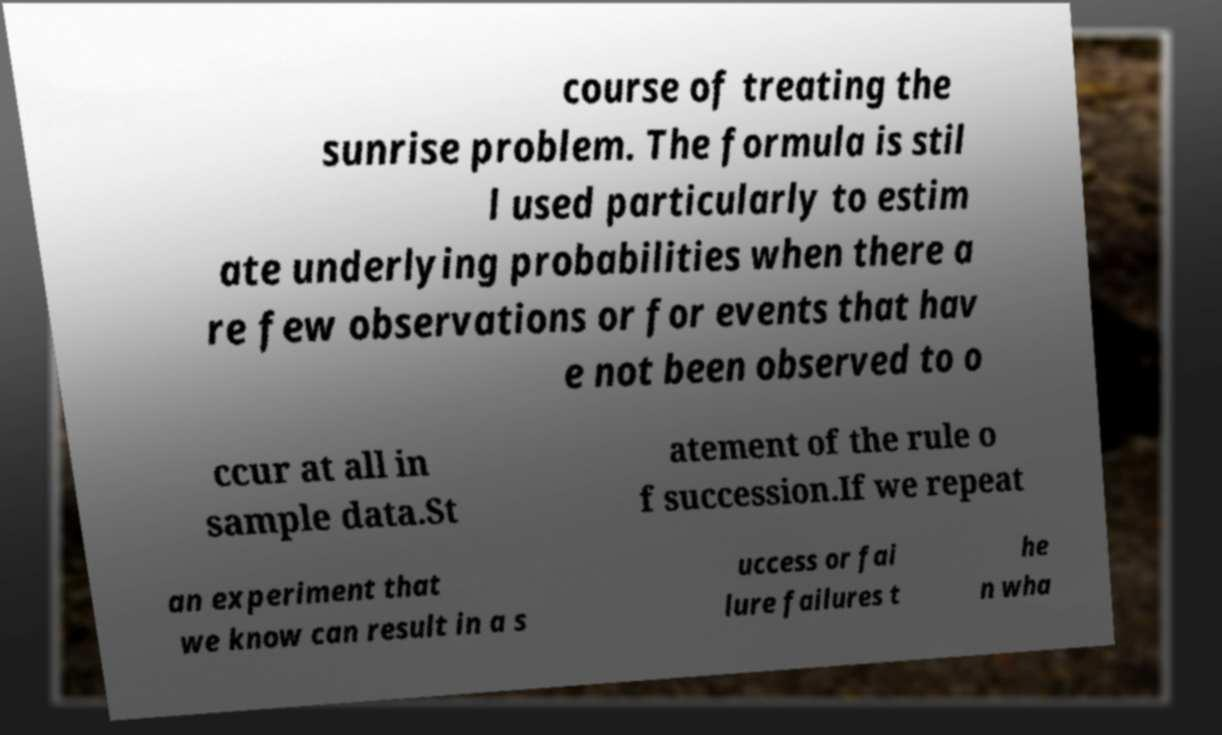Please identify and transcribe the text found in this image. course of treating the sunrise problem. The formula is stil l used particularly to estim ate underlying probabilities when there a re few observations or for events that hav e not been observed to o ccur at all in sample data.St atement of the rule o f succession.If we repeat an experiment that we know can result in a s uccess or fai lure failures t he n wha 